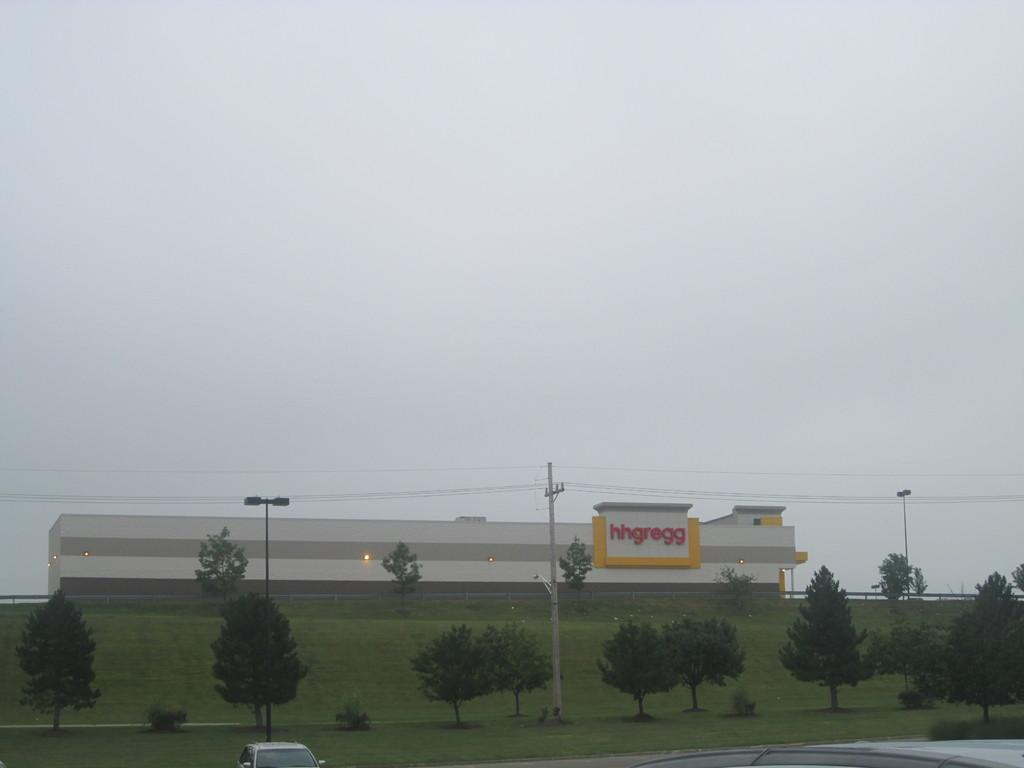What types of objects can be seen in the image? There are vehicles, plants, trees, poles, lights, and a building in the image. Can you describe the natural elements in the image? There are plants and trees in the image. What type of infrastructure is present in the image? There are poles and a building in the image. What is the purpose of the lights in the image? The lights in the image are likely for illumination purposes. What can be seen in the background of the image? The sky is visible in the background of the image. What type of knot is used to tie the page to the shirt in the image? There is no knot, page, or shirt present in the image. What color is the shirt that the page is tied to in the image? There is no shirt or page present in the image, so it is not possible to determine the color of a shirt or the presence of a knot. 